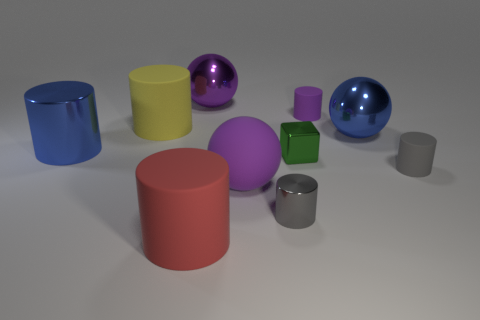Which objects in the image could float in water, and why? The objects that could potentially float are those that appear to be spherical, such as the blue and purple balls. Their shape and possibly their material suggest that they might be hollow or made of a lightweight material, allowing them to displace enough water to float. 